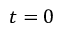<formula> <loc_0><loc_0><loc_500><loc_500>t = 0</formula> 